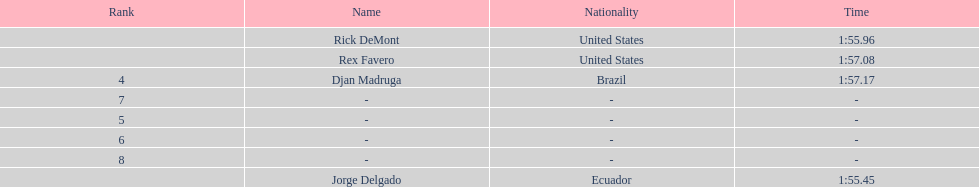What is the time for each name 1:55.45, 1:55.96, 1:57.08, 1:57.17. 